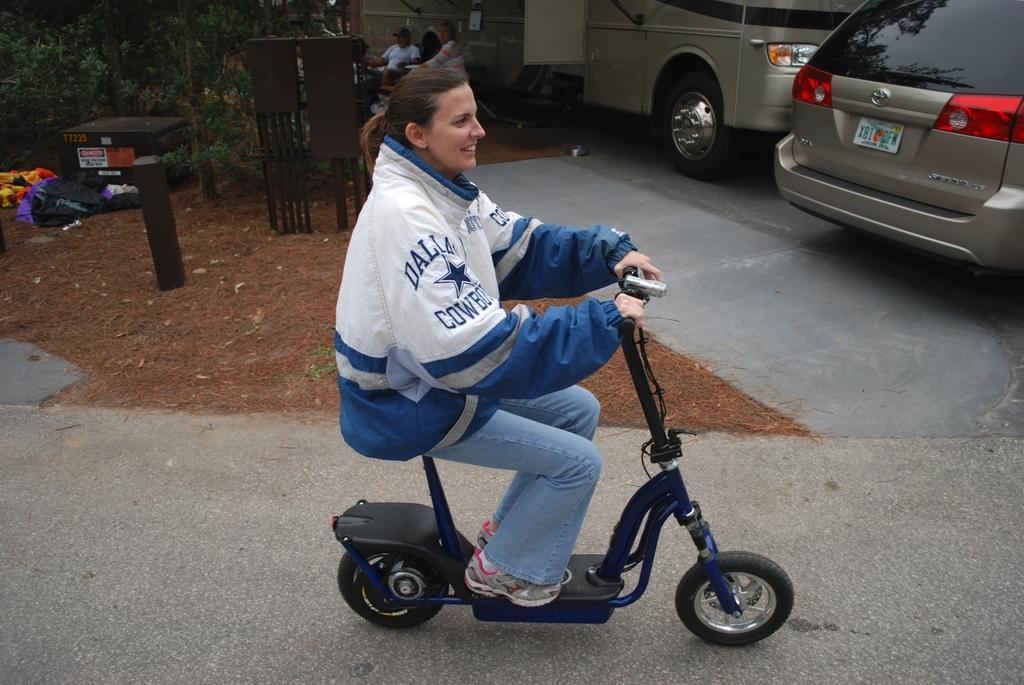How would you summarize this image in a sentence or two? In this image we can see the person riding scooter and there are a few people sitting on the chair. There are vehicles parked on the ground and there are trees, rods, box, clothes, and pillar. 